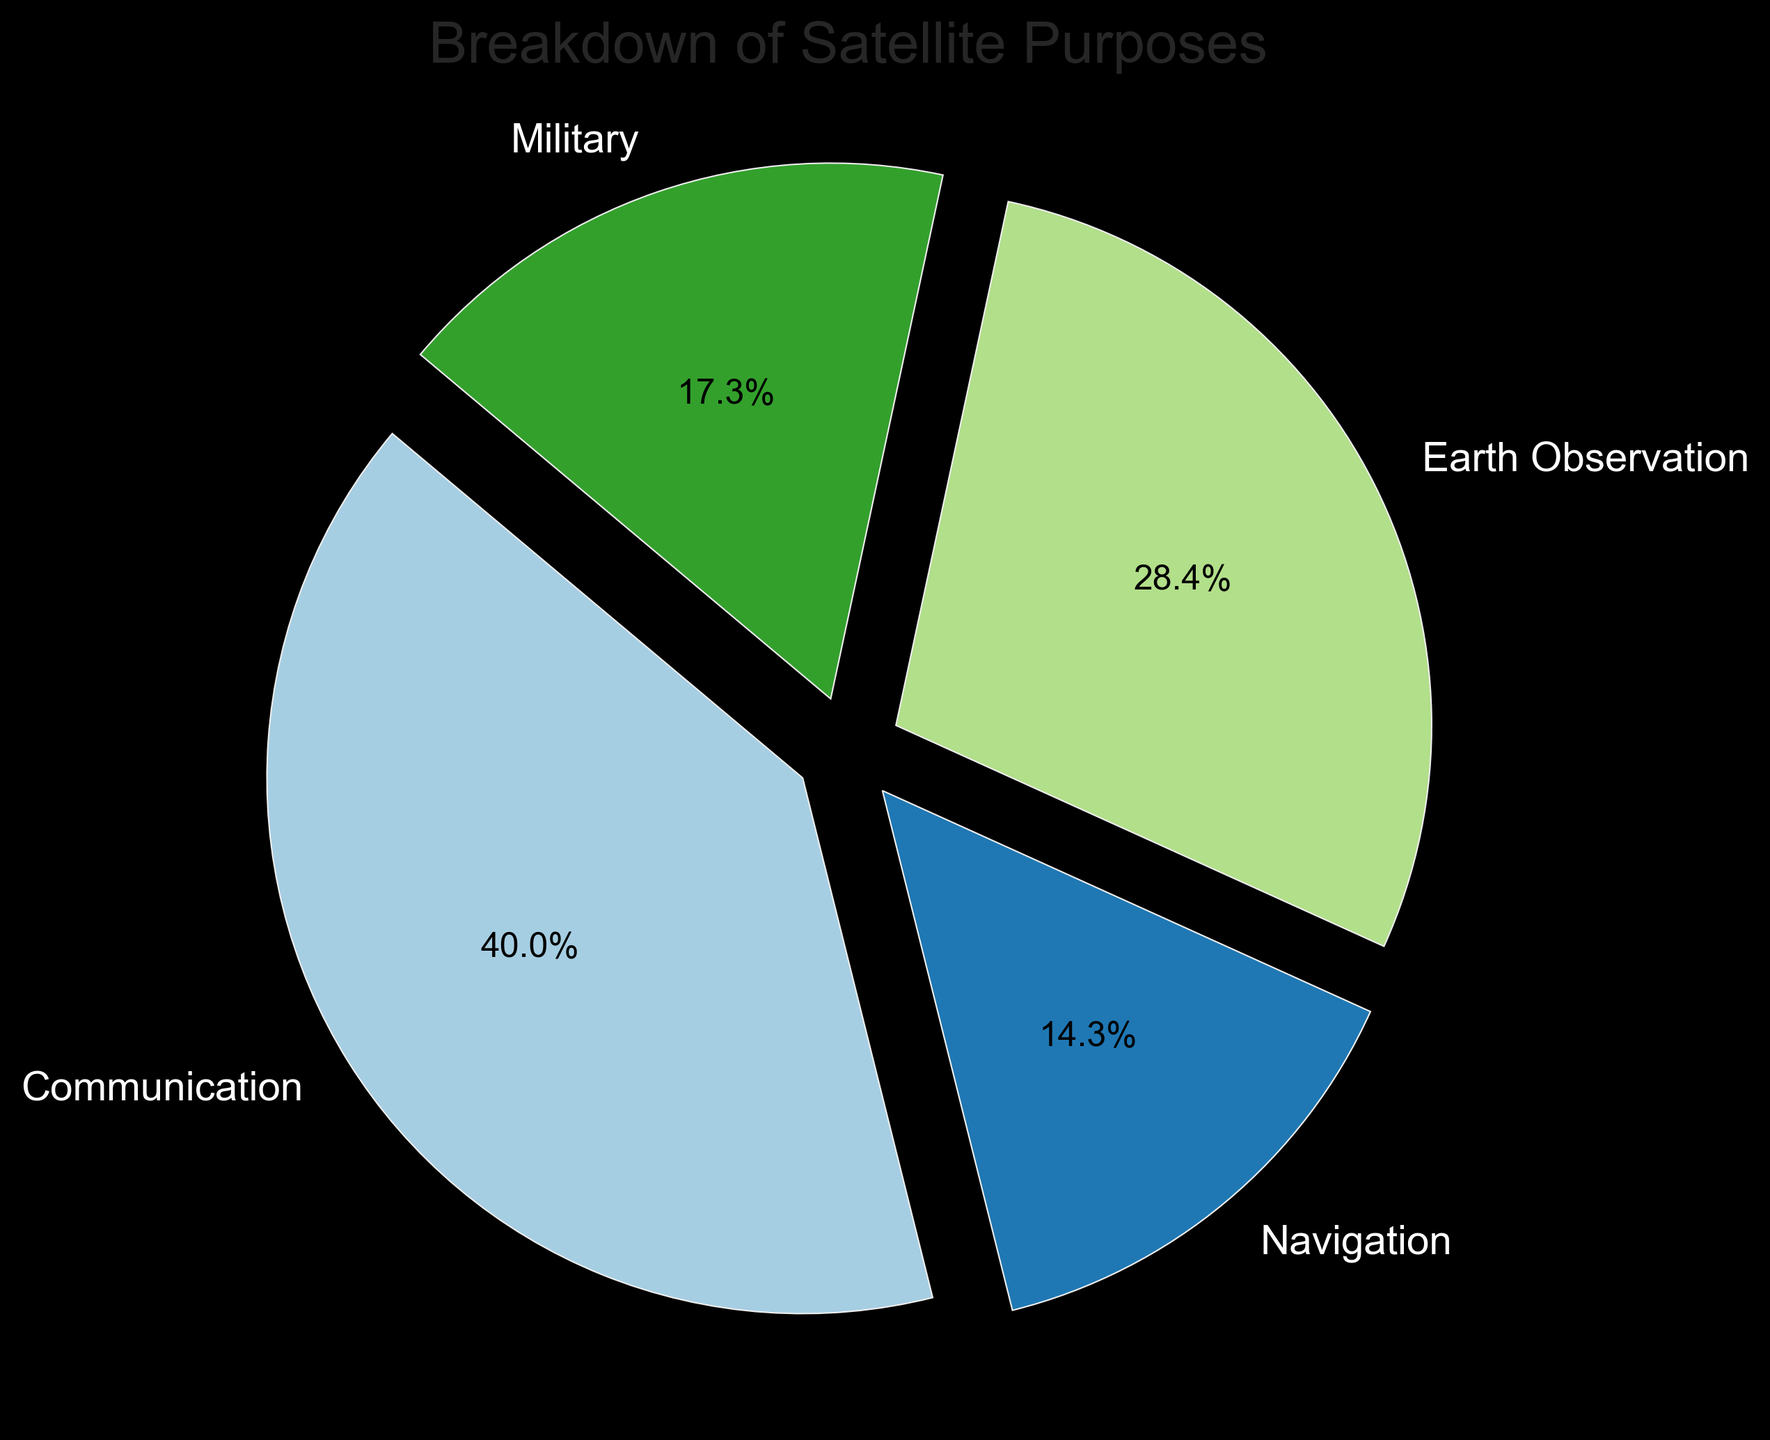What is the percentage of Earth Observation satellites? From the chart, the segment representing Earth Observation satellites shows a label with its percentage. The chart indicates "Earth Observation" as 29.0%.
Answer: 29.0% Which satellite purpose has the highest count? The largest pie segment represents Communication satellites, indicating the highest count among all categories. The chart shows that Communication satellites make up 43.0% of the total.
Answer: Communication By how much does the count of Communication satellites exceed that of Military satellites? The Communication segment represents 1234 satellites, and the Military segment represents 532 satellites. The difference between these counts is 1234 - 532 = 702.
Answer: 702 What is the combined percentage of Navigation and Military satellites? The chart shows Navigation satellites at 15.4% and Military satellites at 18.6%. Adding these percentages together gives 15.4 + 18.6 = 34.0%.
Answer: 34.0% Which satellite purpose has the smallest count, and what is it? The smallest segment represents Navigation satellites. According to the chart, Navigation satellites account for 15.4% with a count of 442 satellites.
Answer: Navigation, 442 Is the count of Earth Observation satellites greater than the combined count of Navigation and Military satellites? Earth Observation satellites count 876. Adding Navigation (442) and Military (532) provides 442 + 532 = 974. Since 876 < 974, the count of Earth Observation satellites is not greater.
Answer: No Which purpose is represented by the segment in the lightest shade of blue? The chart associates colors with purposes. The lightest shade of blue represents the Military purpose.
Answer: Military Are there more Communication satellites than all other purposes combined? Communication satellites are 1234. Other purposes combined (Navigation 442 + Earth Observation 876 + Military 532) sum to 1850. Since 1234 < 1850, there are not more Communication satellites than all other purposes combined.
Answer: No What percentage of satellites are neither for Communication nor Navigation? Removing Communication (43.0%) and Navigation (15.4%) gives 100 - 43.0 - 15.4 = 41.6%.
Answer: 41.6% Which segment of the pie chart shows the smallest explosion? All segments have the same explosion (detached) as indicated by the uniform gap between each segment and the center of the chart.
Answer: All segments are equal 